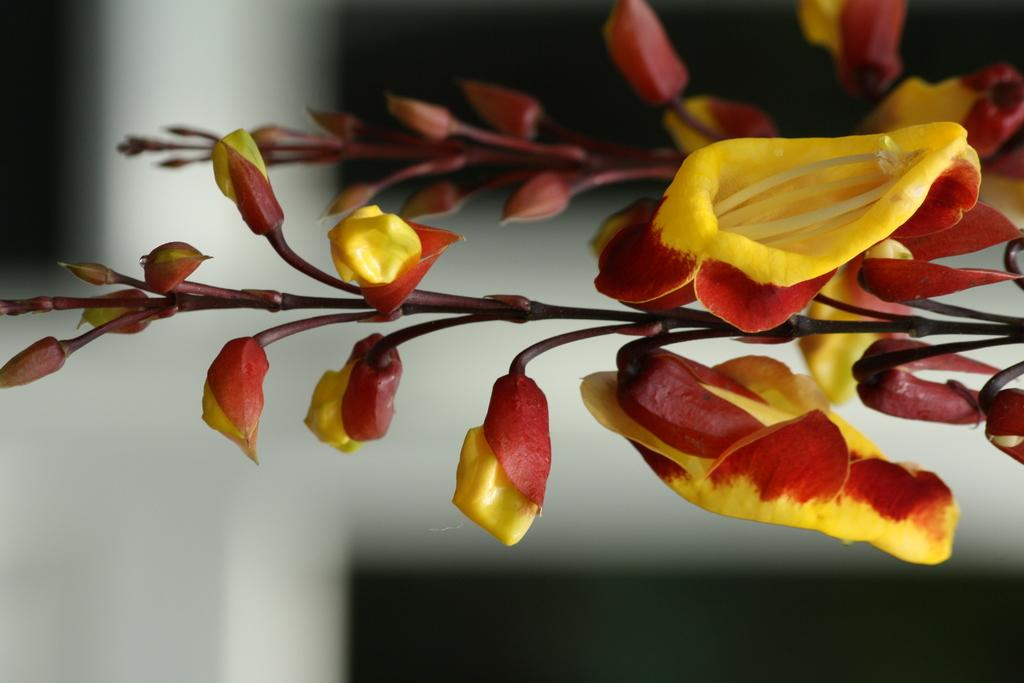What is the main subject of the image? The main subject of the image is a plant. Can you describe the plant in the image? The image is a zoomed-in picture of a plant, so it focuses on the details of the plant rather than showing the entire plant. What type of tent can be seen in the background of the image? There is no tent present in the image, as it is a zoomed-in picture of a plant. 